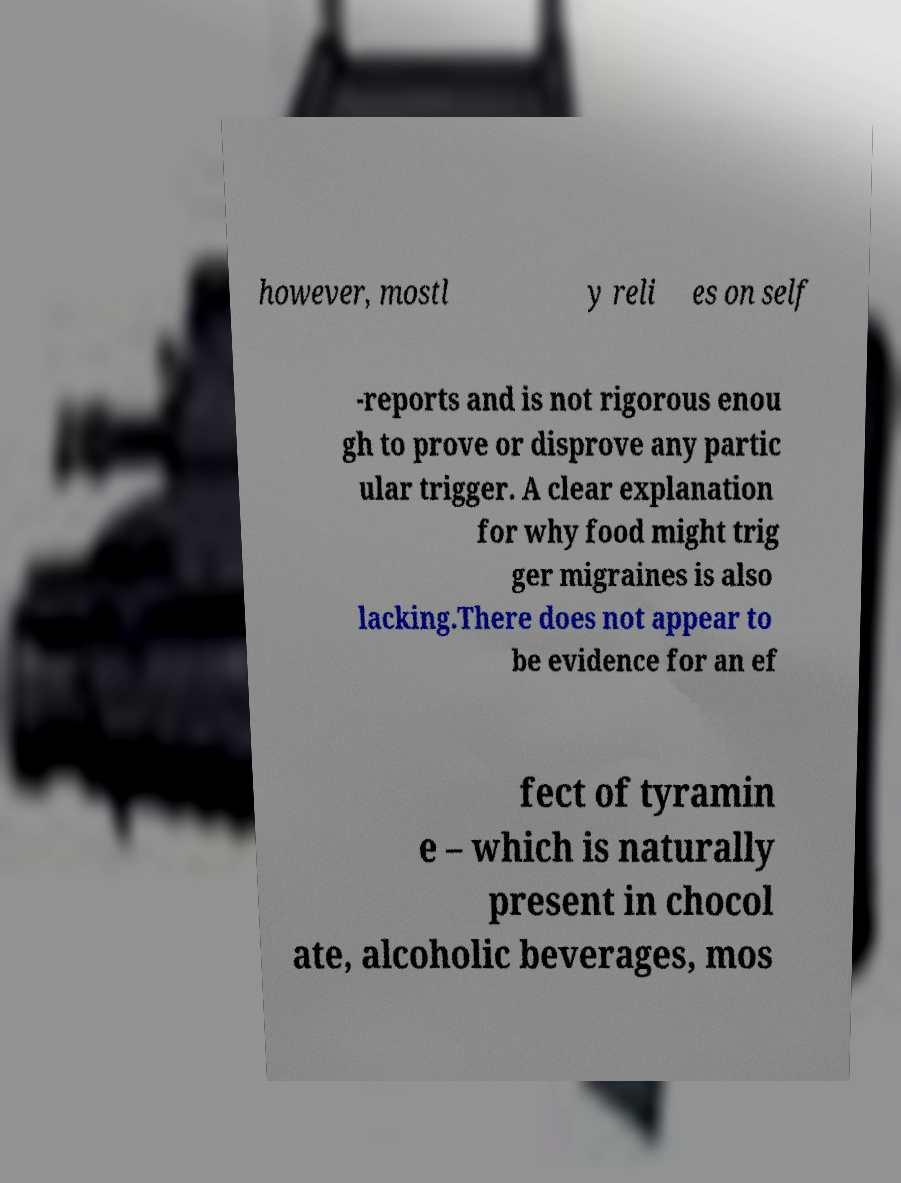I need the written content from this picture converted into text. Can you do that? however, mostl y reli es on self -reports and is not rigorous enou gh to prove or disprove any partic ular trigger. A clear explanation for why food might trig ger migraines is also lacking.There does not appear to be evidence for an ef fect of tyramin e – which is naturally present in chocol ate, alcoholic beverages, mos 